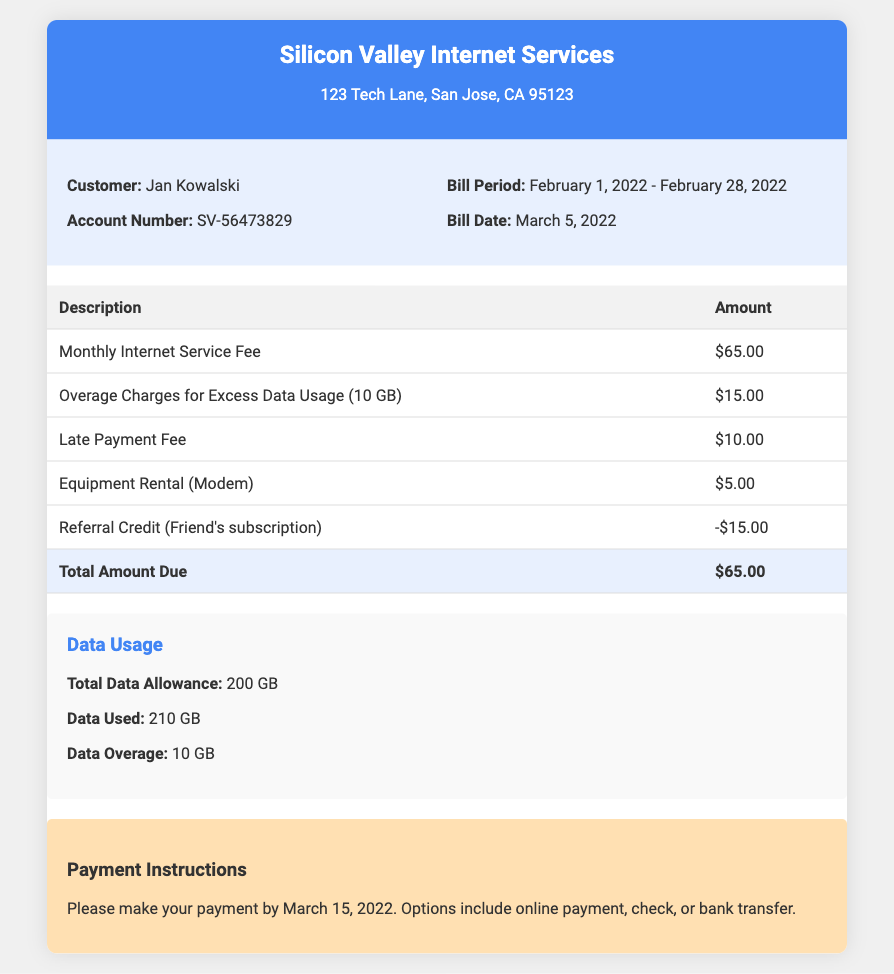What is the customer's name? The customer's name is given in the bill information section of the document.
Answer: Jan Kowalski What is the account number? The account number is mentioned in the bill information section.
Answer: SV-56473829 What is the total amount due? The total amount due is calculated from all charges and credits presented in the table.
Answer: $65.00 How much are the overage charges for excess data usage? The bill shows the specific amount for overage charges in the charges table.
Answer: $15.00 What is the data usage overage? The document details the total data allowance, used data, and overage amount in the data usage section.
Answer: 10 GB What is the bill period? The bill period is specified in the bill information section.
Answer: February 1, 2022 - February 28, 2022 When is the payment due? The payment instructions provide the due date for payment.
Answer: March 15, 2022 What type of credit is listed on the bill? The bill describes a specific type of credit received, which is unique to this billing format.
Answer: Referral Credit How much is the monthly internet service fee? The amount for the monthly internet service fee can be found in the charges table.
Answer: $65.00 What is the equipment rental charge? The charge for equipment rental is detailed in the charges list of the document.
Answer: $5.00 